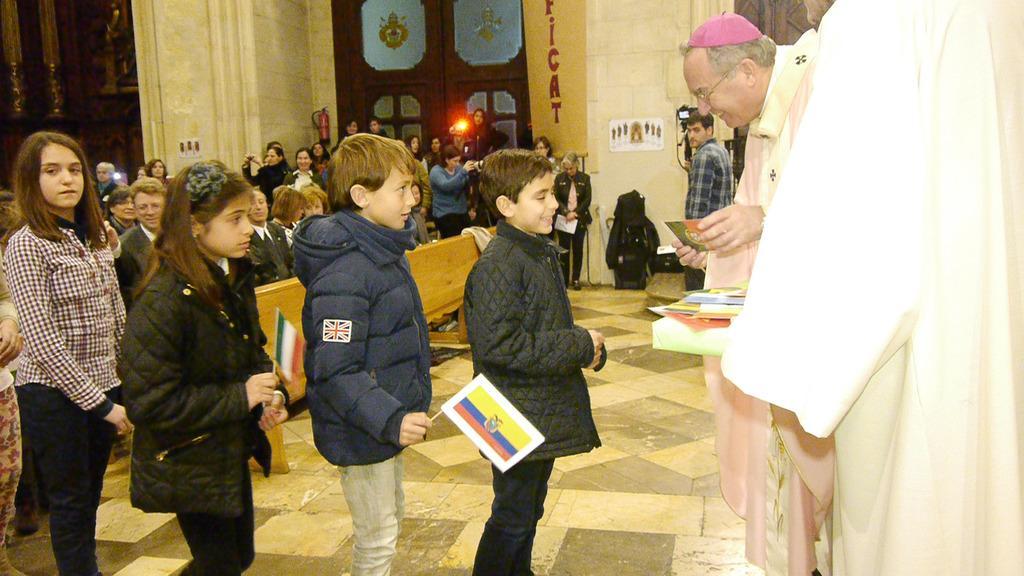Please provide a concise description of this image. In this image, I can see few people standing and few people sitting. I can see two kids holding the flags. This is a door. I can see a fire extinguisher, which is attached to a wall. This looks like a poster. This is the floor. I can see an object, which is black in color. On the right side of the image, I can see another person standing. 